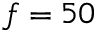Convert formula to latex. <formula><loc_0><loc_0><loc_500><loc_500>f = 5 0</formula> 